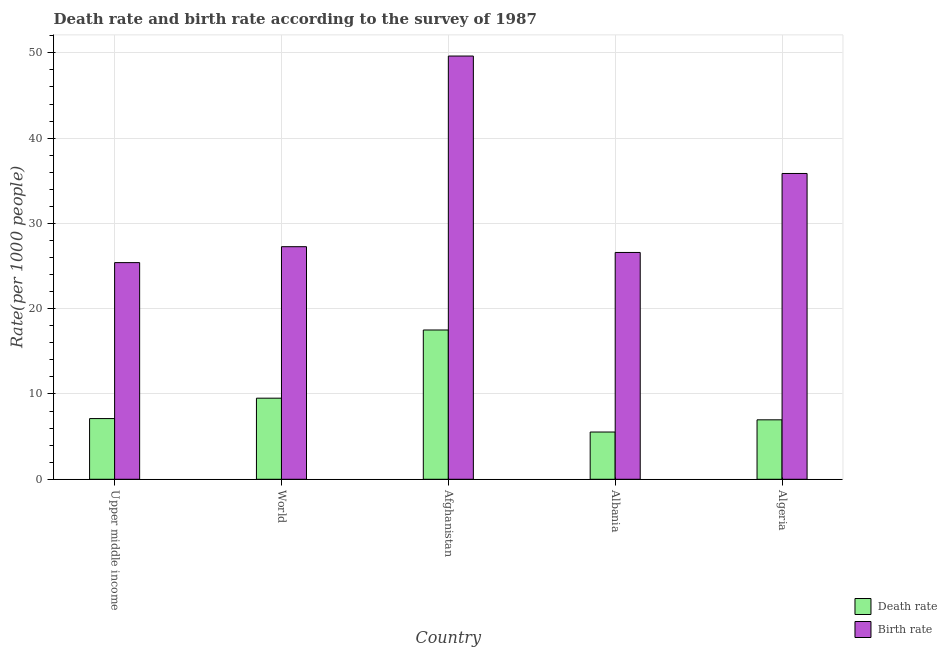How many different coloured bars are there?
Your answer should be very brief. 2. Are the number of bars per tick equal to the number of legend labels?
Keep it short and to the point. Yes. Are the number of bars on each tick of the X-axis equal?
Provide a succinct answer. Yes. How many bars are there on the 5th tick from the right?
Your answer should be compact. 2. What is the label of the 2nd group of bars from the left?
Offer a terse response. World. In how many cases, is the number of bars for a given country not equal to the number of legend labels?
Your answer should be compact. 0. What is the birth rate in Albania?
Offer a very short reply. 26.59. Across all countries, what is the maximum birth rate?
Offer a very short reply. 49.63. Across all countries, what is the minimum death rate?
Offer a terse response. 5.54. In which country was the birth rate maximum?
Offer a terse response. Afghanistan. In which country was the death rate minimum?
Ensure brevity in your answer.  Albania. What is the total death rate in the graph?
Provide a short and direct response. 46.64. What is the difference between the birth rate in Algeria and that in Upper middle income?
Your answer should be very brief. 10.45. What is the difference between the birth rate in Afghanistan and the death rate in Upper middle income?
Your response must be concise. 42.51. What is the average birth rate per country?
Your answer should be very brief. 32.95. What is the difference between the death rate and birth rate in Albania?
Ensure brevity in your answer.  -21.05. What is the ratio of the birth rate in Afghanistan to that in World?
Make the answer very short. 1.82. Is the difference between the death rate in Albania and World greater than the difference between the birth rate in Albania and World?
Give a very brief answer. No. What is the difference between the highest and the second highest birth rate?
Ensure brevity in your answer.  13.77. What is the difference between the highest and the lowest birth rate?
Your response must be concise. 24.22. In how many countries, is the death rate greater than the average death rate taken over all countries?
Ensure brevity in your answer.  2. What does the 2nd bar from the left in World represents?
Provide a succinct answer. Birth rate. What does the 1st bar from the right in World represents?
Provide a short and direct response. Birth rate. How many countries are there in the graph?
Provide a short and direct response. 5. Does the graph contain grids?
Your answer should be compact. Yes. Where does the legend appear in the graph?
Ensure brevity in your answer.  Bottom right. How many legend labels are there?
Ensure brevity in your answer.  2. How are the legend labels stacked?
Offer a very short reply. Vertical. What is the title of the graph?
Offer a very short reply. Death rate and birth rate according to the survey of 1987. What is the label or title of the Y-axis?
Keep it short and to the point. Rate(per 1000 people). What is the Rate(per 1000 people) of Death rate in Upper middle income?
Give a very brief answer. 7.12. What is the Rate(per 1000 people) of Birth rate in Upper middle income?
Make the answer very short. 25.4. What is the Rate(per 1000 people) in Death rate in World?
Your response must be concise. 9.51. What is the Rate(per 1000 people) of Birth rate in World?
Your response must be concise. 27.27. What is the Rate(per 1000 people) in Death rate in Afghanistan?
Make the answer very short. 17.5. What is the Rate(per 1000 people) in Birth rate in Afghanistan?
Provide a succinct answer. 49.63. What is the Rate(per 1000 people) of Death rate in Albania?
Provide a succinct answer. 5.54. What is the Rate(per 1000 people) of Birth rate in Albania?
Provide a succinct answer. 26.59. What is the Rate(per 1000 people) in Death rate in Algeria?
Your response must be concise. 6.97. What is the Rate(per 1000 people) of Birth rate in Algeria?
Give a very brief answer. 35.86. Across all countries, what is the maximum Rate(per 1000 people) of Death rate?
Provide a short and direct response. 17.5. Across all countries, what is the maximum Rate(per 1000 people) of Birth rate?
Keep it short and to the point. 49.63. Across all countries, what is the minimum Rate(per 1000 people) of Death rate?
Provide a short and direct response. 5.54. Across all countries, what is the minimum Rate(per 1000 people) in Birth rate?
Offer a very short reply. 25.4. What is the total Rate(per 1000 people) of Death rate in the graph?
Make the answer very short. 46.64. What is the total Rate(per 1000 people) of Birth rate in the graph?
Make the answer very short. 164.76. What is the difference between the Rate(per 1000 people) of Death rate in Upper middle income and that in World?
Your response must be concise. -2.39. What is the difference between the Rate(per 1000 people) in Birth rate in Upper middle income and that in World?
Make the answer very short. -1.87. What is the difference between the Rate(per 1000 people) of Death rate in Upper middle income and that in Afghanistan?
Give a very brief answer. -10.39. What is the difference between the Rate(per 1000 people) of Birth rate in Upper middle income and that in Afghanistan?
Provide a short and direct response. -24.22. What is the difference between the Rate(per 1000 people) of Death rate in Upper middle income and that in Albania?
Your answer should be very brief. 1.58. What is the difference between the Rate(per 1000 people) of Birth rate in Upper middle income and that in Albania?
Your response must be concise. -1.19. What is the difference between the Rate(per 1000 people) in Death rate in Upper middle income and that in Algeria?
Ensure brevity in your answer.  0.15. What is the difference between the Rate(per 1000 people) in Birth rate in Upper middle income and that in Algeria?
Your answer should be compact. -10.45. What is the difference between the Rate(per 1000 people) in Death rate in World and that in Afghanistan?
Ensure brevity in your answer.  -8. What is the difference between the Rate(per 1000 people) of Birth rate in World and that in Afghanistan?
Offer a terse response. -22.35. What is the difference between the Rate(per 1000 people) in Death rate in World and that in Albania?
Make the answer very short. 3.97. What is the difference between the Rate(per 1000 people) in Birth rate in World and that in Albania?
Ensure brevity in your answer.  0.68. What is the difference between the Rate(per 1000 people) of Death rate in World and that in Algeria?
Your answer should be compact. 2.54. What is the difference between the Rate(per 1000 people) in Birth rate in World and that in Algeria?
Offer a very short reply. -8.58. What is the difference between the Rate(per 1000 people) in Death rate in Afghanistan and that in Albania?
Give a very brief answer. 11.96. What is the difference between the Rate(per 1000 people) of Birth rate in Afghanistan and that in Albania?
Your response must be concise. 23.03. What is the difference between the Rate(per 1000 people) of Death rate in Afghanistan and that in Algeria?
Ensure brevity in your answer.  10.53. What is the difference between the Rate(per 1000 people) of Birth rate in Afghanistan and that in Algeria?
Keep it short and to the point. 13.77. What is the difference between the Rate(per 1000 people) in Death rate in Albania and that in Algeria?
Make the answer very short. -1.43. What is the difference between the Rate(per 1000 people) of Birth rate in Albania and that in Algeria?
Give a very brief answer. -9.26. What is the difference between the Rate(per 1000 people) of Death rate in Upper middle income and the Rate(per 1000 people) of Birth rate in World?
Your answer should be very brief. -20.15. What is the difference between the Rate(per 1000 people) of Death rate in Upper middle income and the Rate(per 1000 people) of Birth rate in Afghanistan?
Keep it short and to the point. -42.51. What is the difference between the Rate(per 1000 people) in Death rate in Upper middle income and the Rate(per 1000 people) in Birth rate in Albania?
Your response must be concise. -19.48. What is the difference between the Rate(per 1000 people) of Death rate in Upper middle income and the Rate(per 1000 people) of Birth rate in Algeria?
Make the answer very short. -28.74. What is the difference between the Rate(per 1000 people) of Death rate in World and the Rate(per 1000 people) of Birth rate in Afghanistan?
Your answer should be compact. -40.12. What is the difference between the Rate(per 1000 people) in Death rate in World and the Rate(per 1000 people) in Birth rate in Albania?
Give a very brief answer. -17.09. What is the difference between the Rate(per 1000 people) in Death rate in World and the Rate(per 1000 people) in Birth rate in Algeria?
Your answer should be compact. -26.35. What is the difference between the Rate(per 1000 people) in Death rate in Afghanistan and the Rate(per 1000 people) in Birth rate in Albania?
Your answer should be compact. -9.09. What is the difference between the Rate(per 1000 people) in Death rate in Afghanistan and the Rate(per 1000 people) in Birth rate in Algeria?
Provide a short and direct response. -18.35. What is the difference between the Rate(per 1000 people) in Death rate in Albania and the Rate(per 1000 people) in Birth rate in Algeria?
Your answer should be very brief. -30.32. What is the average Rate(per 1000 people) of Death rate per country?
Give a very brief answer. 9.33. What is the average Rate(per 1000 people) in Birth rate per country?
Keep it short and to the point. 32.95. What is the difference between the Rate(per 1000 people) in Death rate and Rate(per 1000 people) in Birth rate in Upper middle income?
Your answer should be compact. -18.29. What is the difference between the Rate(per 1000 people) in Death rate and Rate(per 1000 people) in Birth rate in World?
Your answer should be compact. -17.76. What is the difference between the Rate(per 1000 people) of Death rate and Rate(per 1000 people) of Birth rate in Afghanistan?
Ensure brevity in your answer.  -32.12. What is the difference between the Rate(per 1000 people) in Death rate and Rate(per 1000 people) in Birth rate in Albania?
Ensure brevity in your answer.  -21.05. What is the difference between the Rate(per 1000 people) of Death rate and Rate(per 1000 people) of Birth rate in Algeria?
Your answer should be very brief. -28.89. What is the ratio of the Rate(per 1000 people) of Death rate in Upper middle income to that in World?
Keep it short and to the point. 0.75. What is the ratio of the Rate(per 1000 people) in Birth rate in Upper middle income to that in World?
Make the answer very short. 0.93. What is the ratio of the Rate(per 1000 people) of Death rate in Upper middle income to that in Afghanistan?
Provide a succinct answer. 0.41. What is the ratio of the Rate(per 1000 people) of Birth rate in Upper middle income to that in Afghanistan?
Ensure brevity in your answer.  0.51. What is the ratio of the Rate(per 1000 people) of Death rate in Upper middle income to that in Albania?
Offer a terse response. 1.28. What is the ratio of the Rate(per 1000 people) in Birth rate in Upper middle income to that in Albania?
Give a very brief answer. 0.96. What is the ratio of the Rate(per 1000 people) in Death rate in Upper middle income to that in Algeria?
Offer a terse response. 1.02. What is the ratio of the Rate(per 1000 people) of Birth rate in Upper middle income to that in Algeria?
Offer a terse response. 0.71. What is the ratio of the Rate(per 1000 people) in Death rate in World to that in Afghanistan?
Ensure brevity in your answer.  0.54. What is the ratio of the Rate(per 1000 people) in Birth rate in World to that in Afghanistan?
Your response must be concise. 0.55. What is the ratio of the Rate(per 1000 people) in Death rate in World to that in Albania?
Give a very brief answer. 1.72. What is the ratio of the Rate(per 1000 people) in Birth rate in World to that in Albania?
Keep it short and to the point. 1.03. What is the ratio of the Rate(per 1000 people) of Death rate in World to that in Algeria?
Your response must be concise. 1.36. What is the ratio of the Rate(per 1000 people) in Birth rate in World to that in Algeria?
Offer a terse response. 0.76. What is the ratio of the Rate(per 1000 people) of Death rate in Afghanistan to that in Albania?
Your response must be concise. 3.16. What is the ratio of the Rate(per 1000 people) in Birth rate in Afghanistan to that in Albania?
Provide a succinct answer. 1.87. What is the ratio of the Rate(per 1000 people) in Death rate in Afghanistan to that in Algeria?
Your response must be concise. 2.51. What is the ratio of the Rate(per 1000 people) in Birth rate in Afghanistan to that in Algeria?
Offer a very short reply. 1.38. What is the ratio of the Rate(per 1000 people) of Death rate in Albania to that in Algeria?
Provide a short and direct response. 0.79. What is the ratio of the Rate(per 1000 people) in Birth rate in Albania to that in Algeria?
Provide a succinct answer. 0.74. What is the difference between the highest and the second highest Rate(per 1000 people) in Death rate?
Give a very brief answer. 8. What is the difference between the highest and the second highest Rate(per 1000 people) of Birth rate?
Ensure brevity in your answer.  13.77. What is the difference between the highest and the lowest Rate(per 1000 people) of Death rate?
Provide a succinct answer. 11.96. What is the difference between the highest and the lowest Rate(per 1000 people) of Birth rate?
Provide a short and direct response. 24.22. 